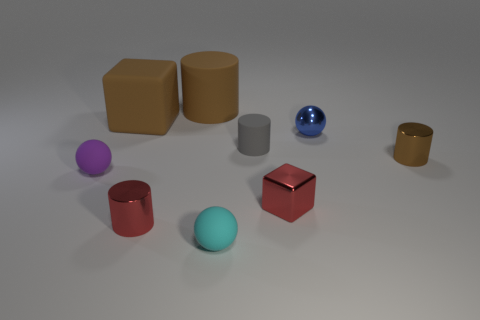What could be the significance of the arrangement of these objects? The arrangement appears intentional, perhaps to illustrate concepts such as geometric shapes, shadows, or spatial relationships. It could serve as an educational tool to demonstrate the properties of different geometries and textures in a controlled lighting environment. 